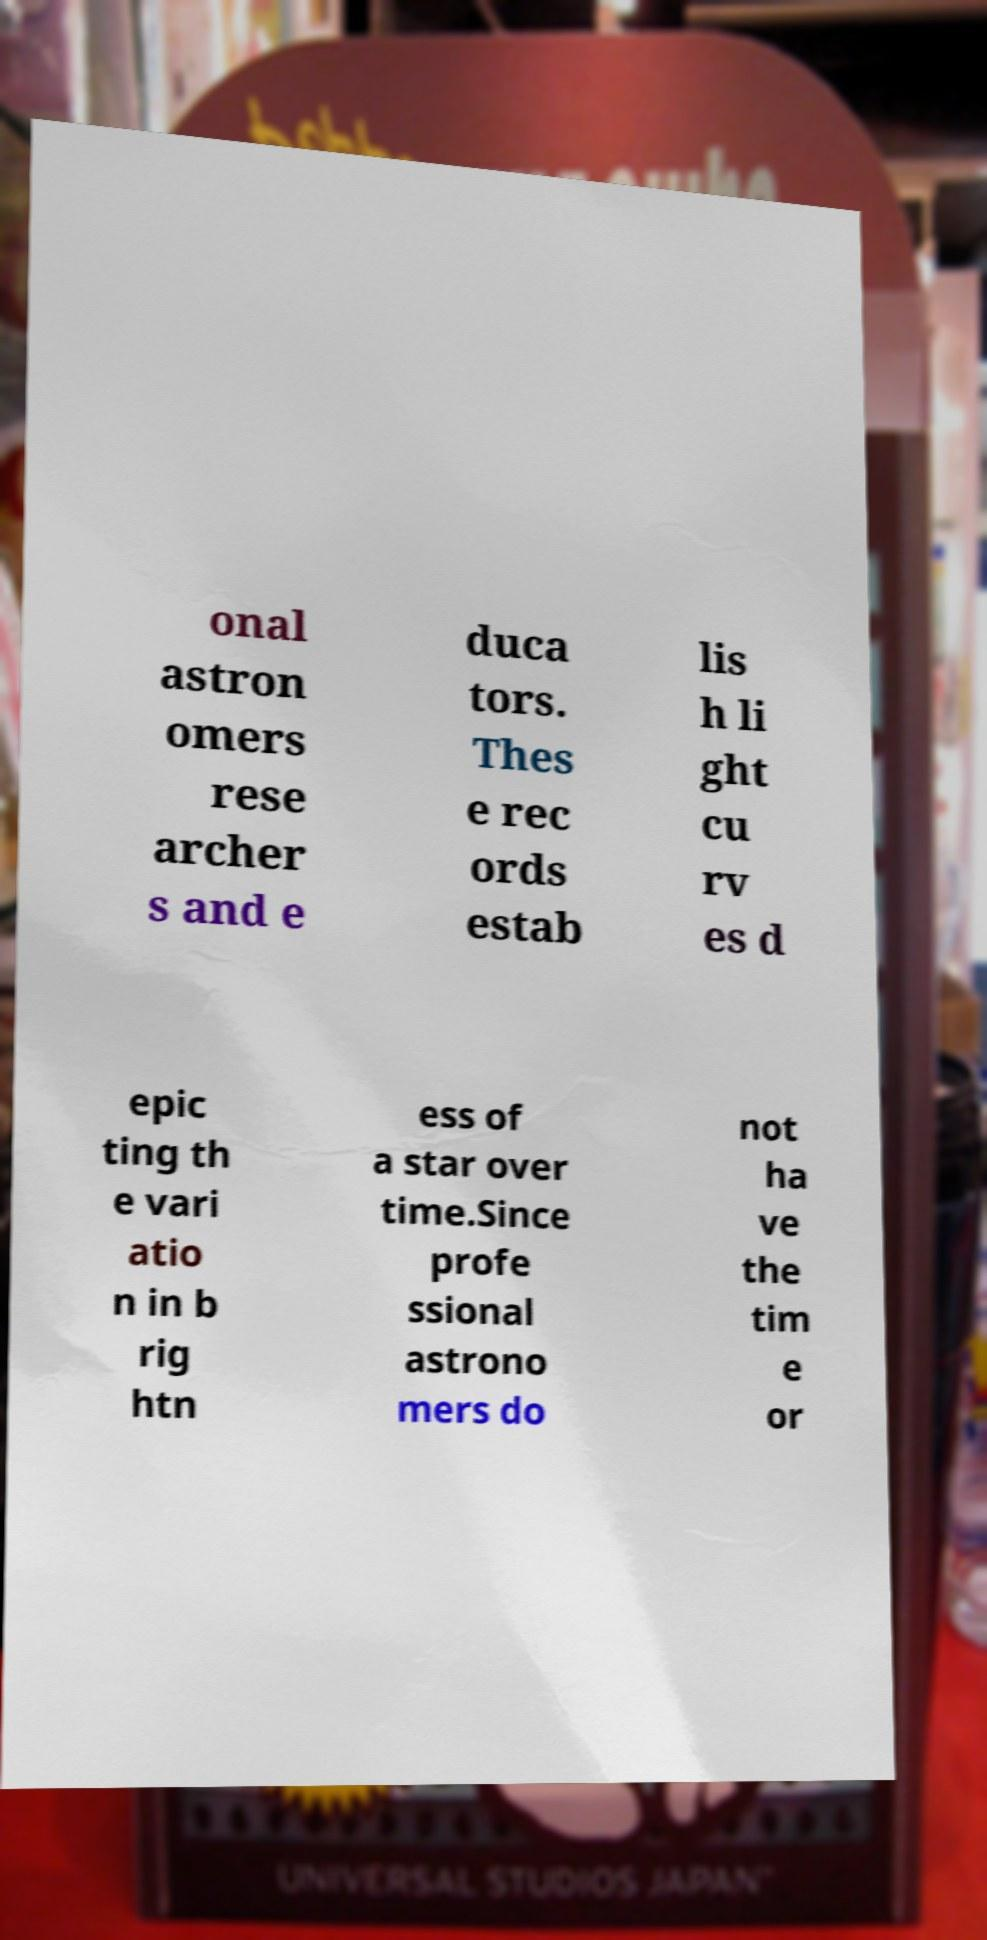Can you read and provide the text displayed in the image?This photo seems to have some interesting text. Can you extract and type it out for me? onal astron omers rese archer s and e duca tors. Thes e rec ords estab lis h li ght cu rv es d epic ting th e vari atio n in b rig htn ess of a star over time.Since profe ssional astrono mers do not ha ve the tim e or 